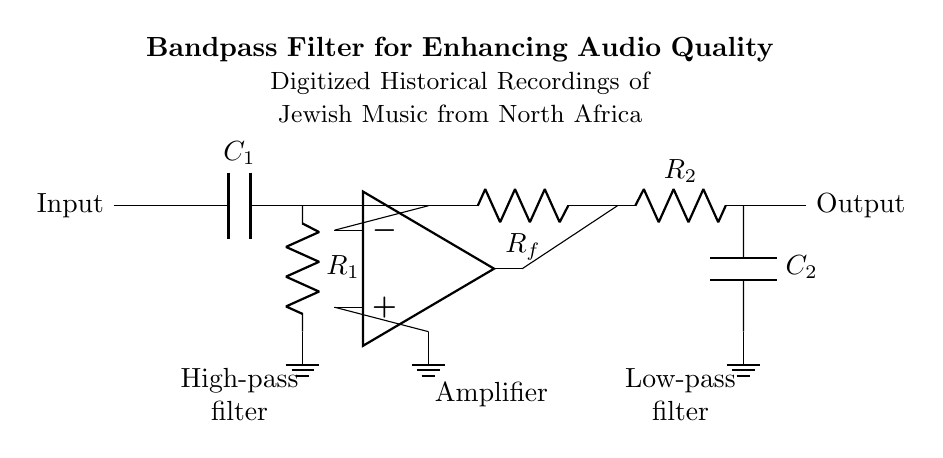What type of filter is represented in the circuit? The circuit is a bandpass filter, which allows only a specific range of frequencies to pass through. This can be inferred from the presence of both a high-pass filter section (to remove low frequencies) and a low-pass filter section (to remove high frequencies), combined together to form a bandpass configuration.
Answer: Bandpass filter What are the components used in the high-pass filter section? The high-pass filter section consists of a capacitor (C1) in series with a resistor (R1). The capacitor allows high frequencies to pass while blocking lower frequencies, and the resistor provides a path to ground, which helps in setting the cutoff frequency.
Answer: Capacitor and resistor What is the role of the operational amplifier in this circuit? The operational amplifier amplifies the voltage signal between its input terminals and can adjust the gain based on the feedback resistor (Rf). This helps to ensure that the signal between the high-pass and low-pass sections is strong enough for effective filtering of the audio signal.
Answer: Amplification Which component defines the cutoff frequency of the low-pass filter? The cutoff frequency of the low-pass filter is defined by the resistor (R2) and the capacitor (C2) in the circuit. The cutoff frequency depends on the values of these components, specifically calculated using the formula involving their values.
Answer: Resistor and capacitor How is the output taken in this circuit? The output is taken from the node between the low-pass filter’s resistor (R2) and capacitor (C2) components, leading to the output terminal of the circuit. This point captures the filtered audio signal after passing through both filtering stages.
Answer: Output terminal 